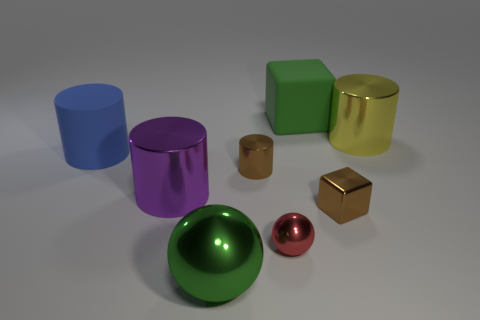Subtract 1 cylinders. How many cylinders are left? 3 Add 1 tiny red metal cylinders. How many objects exist? 9 Subtract all cubes. How many objects are left? 6 Subtract all large green things. Subtract all large yellow cylinders. How many objects are left? 5 Add 8 big blue rubber things. How many big blue rubber things are left? 9 Add 4 tiny gray matte cylinders. How many tiny gray matte cylinders exist? 4 Subtract 1 blue cylinders. How many objects are left? 7 